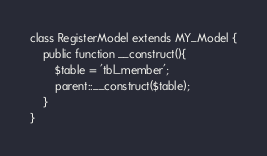<code> <loc_0><loc_0><loc_500><loc_500><_PHP_>
class RegisterModel extends MY_Model {
    public function __construct(){
        $table = 'tbl_member';
        parent::__construct($table);
    }
}</code> 